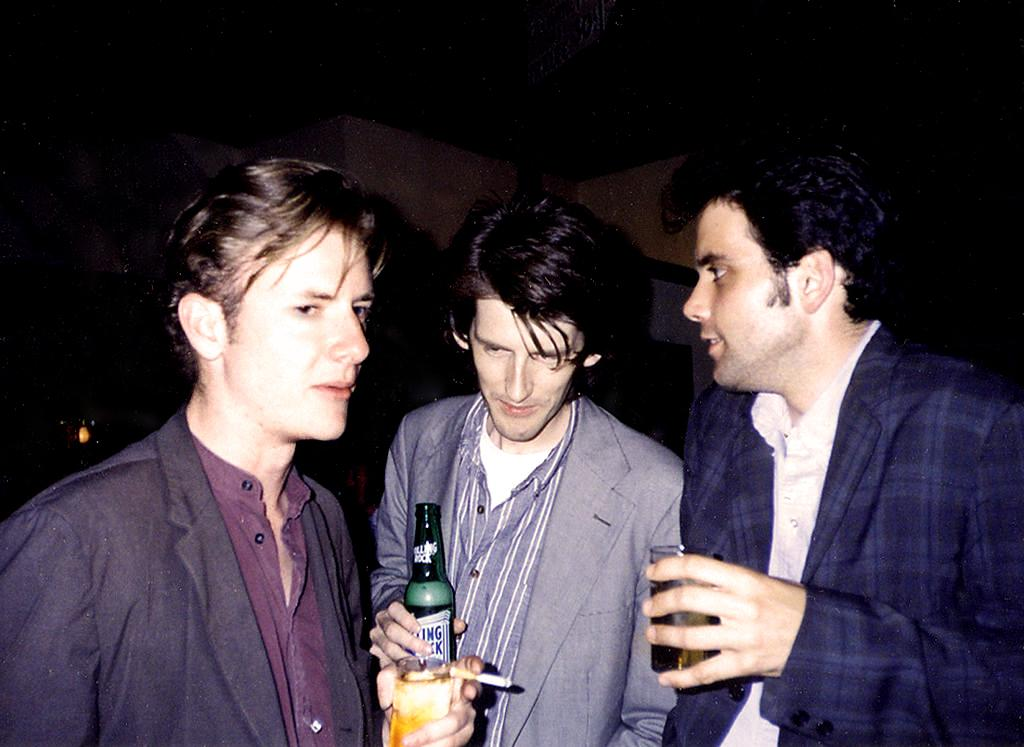How many people are in the image? There are three people standing in the image. What is the person in the center holding? The person in the center is holding a bottle. What type of lace is being used to tie the thing in the image? There is no lace or thing present in the image. 